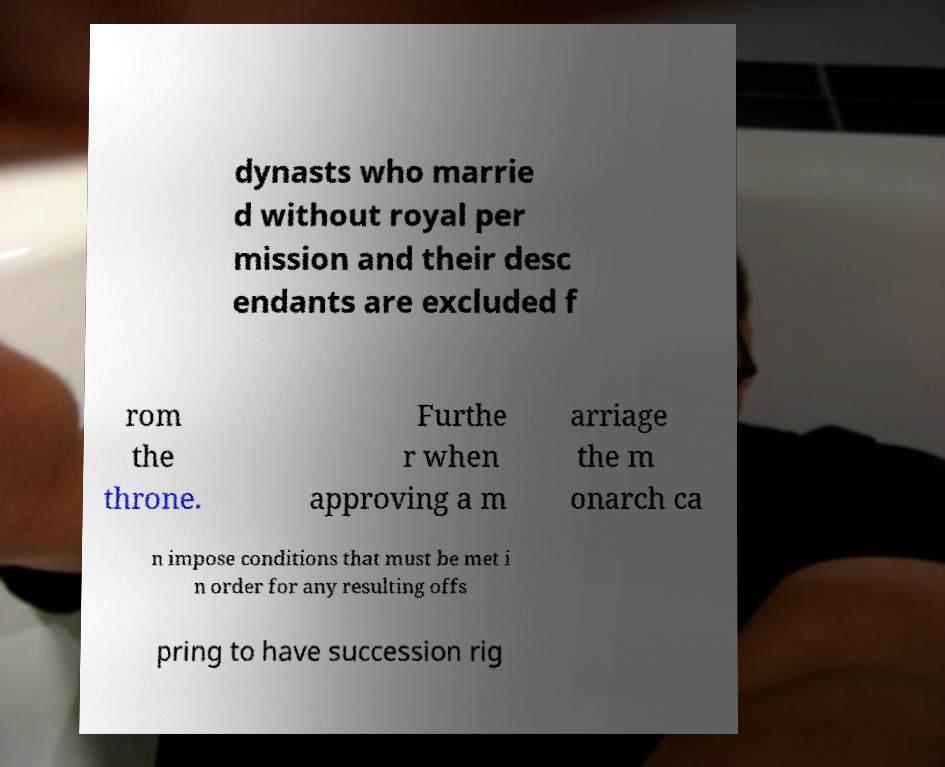Please identify and transcribe the text found in this image. dynasts who marrie d without royal per mission and their desc endants are excluded f rom the throne. Furthe r when approving a m arriage the m onarch ca n impose conditions that must be met i n order for any resulting offs pring to have succession rig 